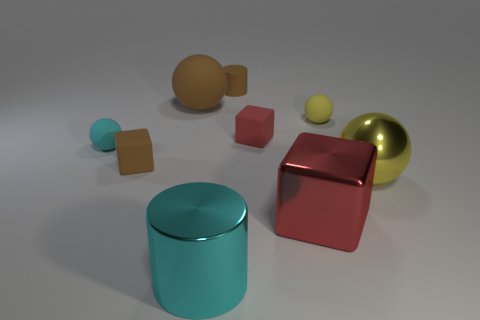Add 1 tiny yellow rubber balls. How many objects exist? 10 Subtract all cubes. How many objects are left? 6 Subtract all cyan metal objects. Subtract all brown objects. How many objects are left? 5 Add 3 tiny cyan rubber spheres. How many tiny cyan rubber spheres are left? 4 Add 5 large gray matte cylinders. How many large gray matte cylinders exist? 5 Subtract 0 yellow cubes. How many objects are left? 9 